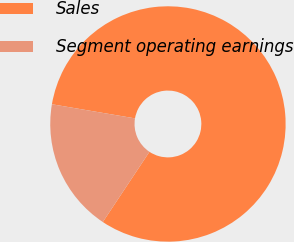Convert chart. <chart><loc_0><loc_0><loc_500><loc_500><pie_chart><fcel>Sales<fcel>Segment operating earnings<nl><fcel>81.65%<fcel>18.35%<nl></chart> 